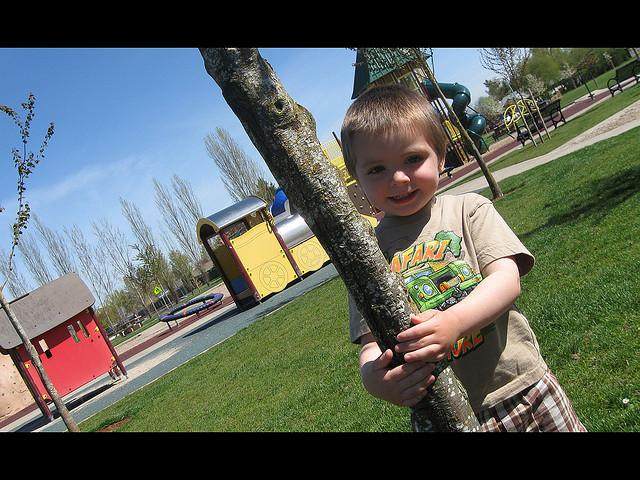At which location does the child hold the tree?

Choices:
A) car wash
B) dairy barn
C) playground
D) mall playground 